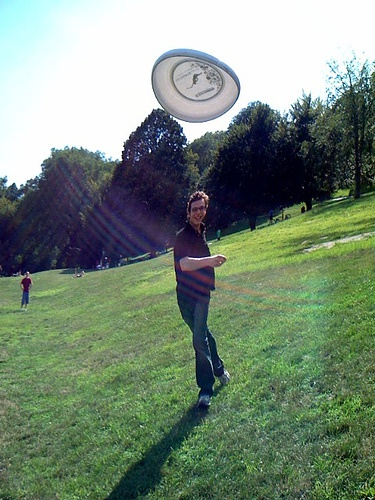Describe the objects in this image and their specific colors. I can see people in lightblue, black, navy, gray, and purple tones, frisbee in lightblue, darkgray, lightgray, and gray tones, people in lightblue, navy, gray, and darkgray tones, people in lightblue, black, teal, and darkgreen tones, and people in lightblue, black, and olive tones in this image. 